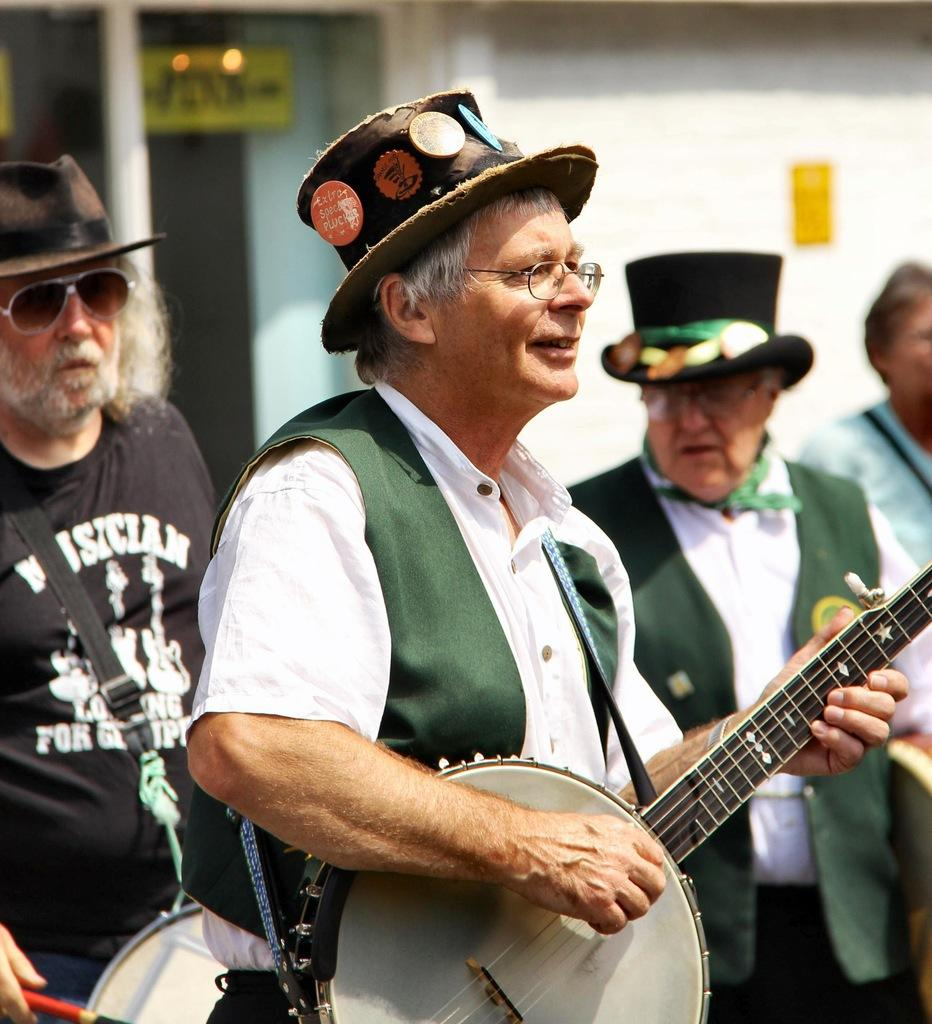What are the two men in the image doing? The two men in the image are playing musical instruments. Can you describe the people standing on the right side of the image? There are two persons standing on the right side of the image. What type of parcel is being delivered to the brothers in the image? There are no brothers or parcel present in the image; it features two men playing musical instruments and two persons standing on the right side. Can you tell me which person is holding the bone in the image? There is no bone present in the image. 